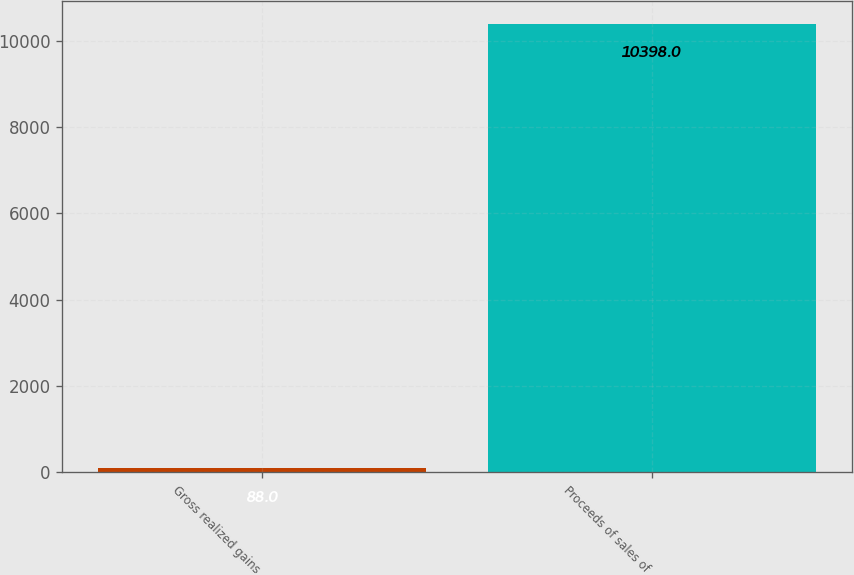Convert chart. <chart><loc_0><loc_0><loc_500><loc_500><bar_chart><fcel>Gross realized gains<fcel>Proceeds of sales of<nl><fcel>88<fcel>10398<nl></chart> 